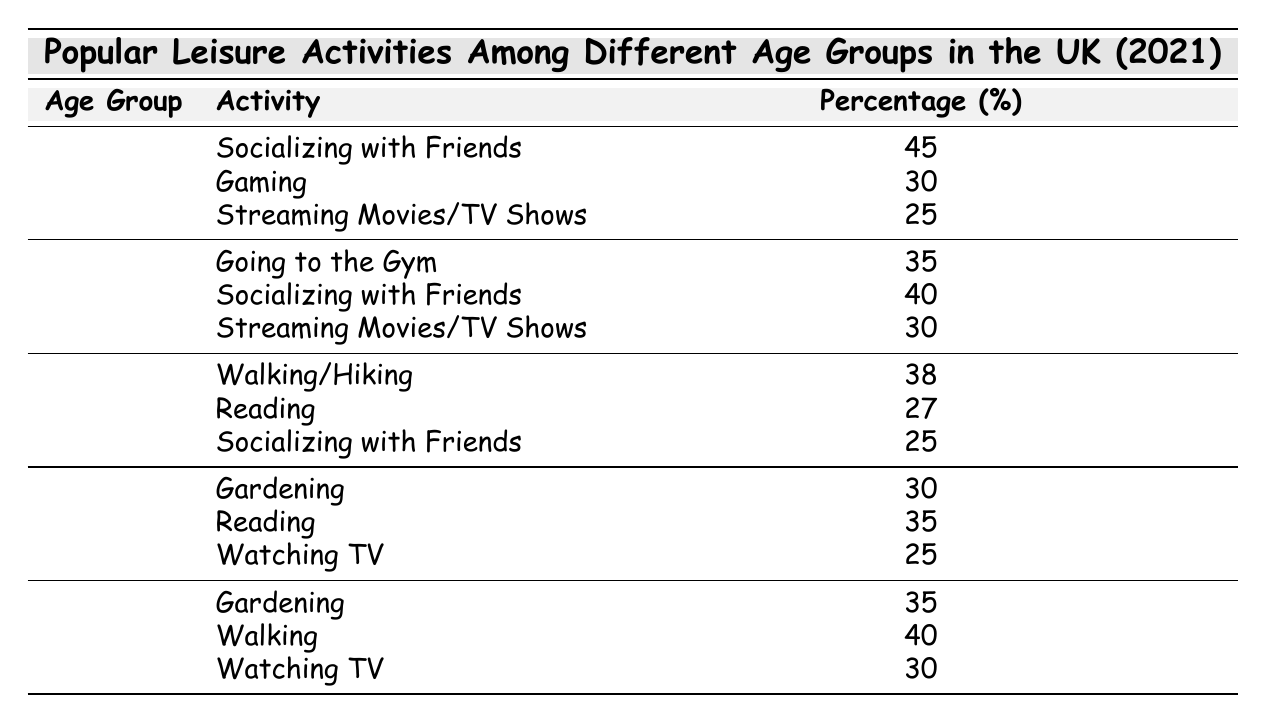What is the most popular leisure activity among the 18-24 age group? According to the table, the highest percentage for the 18-24 age group is for "Socializing with Friends," which is rated at 45%.
Answer: 45% Which activity has the highest percentage for individuals aged 55 and over? From the data, the activity with the highest percentage for the 55+ age group is "Walking" at 40%.
Answer: 40% Is "Reading" a more popular activity in the 45-54 age group than in the 35-44 age group? For the 45-54 age group, "Reading" is at 35%, while in the 35-44 age group, it is at 27%. Therefore, yes, it is more popular for the 45-54 age group.
Answer: Yes What percentage of 25-34 year-olds engage in Socializing with Friends? The table indicates that 40% of individuals in the 25-34 age group engage in Socializing with Friends.
Answer: 40% What is the average percentage of those aged 35-44 who enjoy Socializing with Friends, Walking/Hiking, and Reading? The percentages for 35-44 age group are 25% for Socializing with Friends, 38% for Walking/Hiking, and 27% for Reading. Adding these gives 25 + 38 + 27 = 90. Dividing by 3 (the number of activities) gives an average of 90/3 = 30%.
Answer: 30% How does gaming popularity in the 18-24 age group compare with gardening in the 55+ age group? In the 18-24 age group, Gaming is at 30%, while Gardening in the 55+ age group is at 35%. Therefore, Gardening is more popular than Gaming.
Answer: No Which age group has the highest percentage for the activity "Streaming Movies/TV Shows"? By examining the table, the highest percentage for Streaming Movies/TV Shows is found in the 25-34 age group at 30%.
Answer: 30% How many leisure activities have been listed for each age group? Each age group in the table has three leisure activities listed, as indicated by the formatting of the data.
Answer: 3 